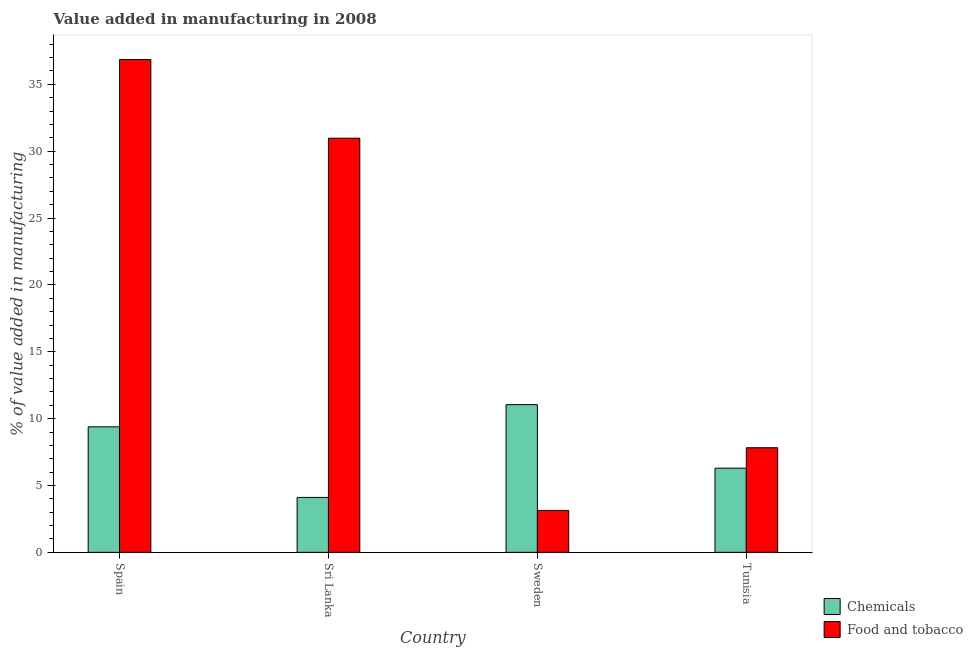How many different coloured bars are there?
Provide a short and direct response. 2. Are the number of bars per tick equal to the number of legend labels?
Provide a short and direct response. Yes. Are the number of bars on each tick of the X-axis equal?
Your response must be concise. Yes. How many bars are there on the 3rd tick from the left?
Make the answer very short. 2. How many bars are there on the 2nd tick from the right?
Offer a terse response. 2. What is the value added by manufacturing food and tobacco in Sri Lanka?
Offer a very short reply. 30.97. Across all countries, what is the maximum value added by manufacturing food and tobacco?
Your answer should be compact. 36.86. Across all countries, what is the minimum value added by  manufacturing chemicals?
Your answer should be compact. 4.11. In which country was the value added by  manufacturing chemicals maximum?
Keep it short and to the point. Sweden. What is the total value added by manufacturing food and tobacco in the graph?
Your answer should be very brief. 78.79. What is the difference between the value added by  manufacturing chemicals in Spain and that in Tunisia?
Keep it short and to the point. 3.09. What is the difference between the value added by manufacturing food and tobacco in Tunisia and the value added by  manufacturing chemicals in Sweden?
Provide a short and direct response. -3.22. What is the average value added by  manufacturing chemicals per country?
Offer a terse response. 7.71. What is the difference between the value added by  manufacturing chemicals and value added by manufacturing food and tobacco in Sri Lanka?
Offer a terse response. -26.87. What is the ratio of the value added by  manufacturing chemicals in Sri Lanka to that in Tunisia?
Your response must be concise. 0.65. Is the difference between the value added by  manufacturing chemicals in Sweden and Tunisia greater than the difference between the value added by manufacturing food and tobacco in Sweden and Tunisia?
Give a very brief answer. Yes. What is the difference between the highest and the second highest value added by  manufacturing chemicals?
Your response must be concise. 1.66. What is the difference between the highest and the lowest value added by manufacturing food and tobacco?
Provide a succinct answer. 33.73. Is the sum of the value added by  manufacturing chemicals in Spain and Sweden greater than the maximum value added by manufacturing food and tobacco across all countries?
Your answer should be very brief. No. What does the 2nd bar from the left in Sri Lanka represents?
Provide a succinct answer. Food and tobacco. What does the 2nd bar from the right in Spain represents?
Provide a short and direct response. Chemicals. How many countries are there in the graph?
Give a very brief answer. 4. Does the graph contain any zero values?
Provide a succinct answer. No. Does the graph contain grids?
Offer a terse response. No. Where does the legend appear in the graph?
Give a very brief answer. Bottom right. What is the title of the graph?
Offer a terse response. Value added in manufacturing in 2008. Does "current US$" appear as one of the legend labels in the graph?
Your response must be concise. No. What is the label or title of the X-axis?
Give a very brief answer. Country. What is the label or title of the Y-axis?
Make the answer very short. % of value added in manufacturing. What is the % of value added in manufacturing of Chemicals in Spain?
Provide a short and direct response. 9.39. What is the % of value added in manufacturing of Food and tobacco in Spain?
Provide a short and direct response. 36.86. What is the % of value added in manufacturing in Chemicals in Sri Lanka?
Your answer should be very brief. 4.11. What is the % of value added in manufacturing of Food and tobacco in Sri Lanka?
Offer a terse response. 30.97. What is the % of value added in manufacturing of Chemicals in Sweden?
Provide a succinct answer. 11.05. What is the % of value added in manufacturing of Food and tobacco in Sweden?
Keep it short and to the point. 3.13. What is the % of value added in manufacturing in Chemicals in Tunisia?
Give a very brief answer. 6.3. What is the % of value added in manufacturing of Food and tobacco in Tunisia?
Provide a short and direct response. 7.82. Across all countries, what is the maximum % of value added in manufacturing in Chemicals?
Ensure brevity in your answer.  11.05. Across all countries, what is the maximum % of value added in manufacturing of Food and tobacco?
Make the answer very short. 36.86. Across all countries, what is the minimum % of value added in manufacturing of Chemicals?
Provide a succinct answer. 4.11. Across all countries, what is the minimum % of value added in manufacturing in Food and tobacco?
Ensure brevity in your answer.  3.13. What is the total % of value added in manufacturing in Chemicals in the graph?
Provide a short and direct response. 30.84. What is the total % of value added in manufacturing in Food and tobacco in the graph?
Make the answer very short. 78.79. What is the difference between the % of value added in manufacturing in Chemicals in Spain and that in Sri Lanka?
Provide a short and direct response. 5.28. What is the difference between the % of value added in manufacturing of Food and tobacco in Spain and that in Sri Lanka?
Provide a short and direct response. 5.88. What is the difference between the % of value added in manufacturing in Chemicals in Spain and that in Sweden?
Your answer should be very brief. -1.66. What is the difference between the % of value added in manufacturing in Food and tobacco in Spain and that in Sweden?
Your answer should be compact. 33.73. What is the difference between the % of value added in manufacturing of Chemicals in Spain and that in Tunisia?
Give a very brief answer. 3.09. What is the difference between the % of value added in manufacturing in Food and tobacco in Spain and that in Tunisia?
Offer a very short reply. 29.04. What is the difference between the % of value added in manufacturing of Chemicals in Sri Lanka and that in Sweden?
Your answer should be compact. -6.94. What is the difference between the % of value added in manufacturing of Food and tobacco in Sri Lanka and that in Sweden?
Your answer should be very brief. 27.84. What is the difference between the % of value added in manufacturing in Chemicals in Sri Lanka and that in Tunisia?
Make the answer very short. -2.19. What is the difference between the % of value added in manufacturing of Food and tobacco in Sri Lanka and that in Tunisia?
Provide a succinct answer. 23.15. What is the difference between the % of value added in manufacturing of Chemicals in Sweden and that in Tunisia?
Keep it short and to the point. 4.75. What is the difference between the % of value added in manufacturing of Food and tobacco in Sweden and that in Tunisia?
Your response must be concise. -4.69. What is the difference between the % of value added in manufacturing in Chemicals in Spain and the % of value added in manufacturing in Food and tobacco in Sri Lanka?
Your response must be concise. -21.59. What is the difference between the % of value added in manufacturing of Chemicals in Spain and the % of value added in manufacturing of Food and tobacco in Sweden?
Offer a terse response. 6.25. What is the difference between the % of value added in manufacturing of Chemicals in Spain and the % of value added in manufacturing of Food and tobacco in Tunisia?
Offer a terse response. 1.56. What is the difference between the % of value added in manufacturing in Chemicals in Sri Lanka and the % of value added in manufacturing in Food and tobacco in Sweden?
Make the answer very short. 0.97. What is the difference between the % of value added in manufacturing in Chemicals in Sri Lanka and the % of value added in manufacturing in Food and tobacco in Tunisia?
Offer a terse response. -3.72. What is the difference between the % of value added in manufacturing in Chemicals in Sweden and the % of value added in manufacturing in Food and tobacco in Tunisia?
Keep it short and to the point. 3.22. What is the average % of value added in manufacturing in Chemicals per country?
Make the answer very short. 7.71. What is the average % of value added in manufacturing of Food and tobacco per country?
Make the answer very short. 19.7. What is the difference between the % of value added in manufacturing of Chemicals and % of value added in manufacturing of Food and tobacco in Spain?
Your answer should be very brief. -27.47. What is the difference between the % of value added in manufacturing in Chemicals and % of value added in manufacturing in Food and tobacco in Sri Lanka?
Give a very brief answer. -26.87. What is the difference between the % of value added in manufacturing of Chemicals and % of value added in manufacturing of Food and tobacco in Sweden?
Your response must be concise. 7.91. What is the difference between the % of value added in manufacturing of Chemicals and % of value added in manufacturing of Food and tobacco in Tunisia?
Offer a terse response. -1.53. What is the ratio of the % of value added in manufacturing in Chemicals in Spain to that in Sri Lanka?
Make the answer very short. 2.29. What is the ratio of the % of value added in manufacturing in Food and tobacco in Spain to that in Sri Lanka?
Your answer should be very brief. 1.19. What is the ratio of the % of value added in manufacturing in Chemicals in Spain to that in Sweden?
Make the answer very short. 0.85. What is the ratio of the % of value added in manufacturing in Food and tobacco in Spain to that in Sweden?
Your answer should be compact. 11.76. What is the ratio of the % of value added in manufacturing in Chemicals in Spain to that in Tunisia?
Give a very brief answer. 1.49. What is the ratio of the % of value added in manufacturing of Food and tobacco in Spain to that in Tunisia?
Give a very brief answer. 4.71. What is the ratio of the % of value added in manufacturing of Chemicals in Sri Lanka to that in Sweden?
Your answer should be very brief. 0.37. What is the ratio of the % of value added in manufacturing in Food and tobacco in Sri Lanka to that in Sweden?
Your answer should be compact. 9.89. What is the ratio of the % of value added in manufacturing of Chemicals in Sri Lanka to that in Tunisia?
Provide a succinct answer. 0.65. What is the ratio of the % of value added in manufacturing in Food and tobacco in Sri Lanka to that in Tunisia?
Your response must be concise. 3.96. What is the ratio of the % of value added in manufacturing in Chemicals in Sweden to that in Tunisia?
Ensure brevity in your answer.  1.75. What is the ratio of the % of value added in manufacturing of Food and tobacco in Sweden to that in Tunisia?
Keep it short and to the point. 0.4. What is the difference between the highest and the second highest % of value added in manufacturing in Chemicals?
Provide a short and direct response. 1.66. What is the difference between the highest and the second highest % of value added in manufacturing of Food and tobacco?
Offer a very short reply. 5.88. What is the difference between the highest and the lowest % of value added in manufacturing in Chemicals?
Offer a very short reply. 6.94. What is the difference between the highest and the lowest % of value added in manufacturing of Food and tobacco?
Provide a succinct answer. 33.73. 